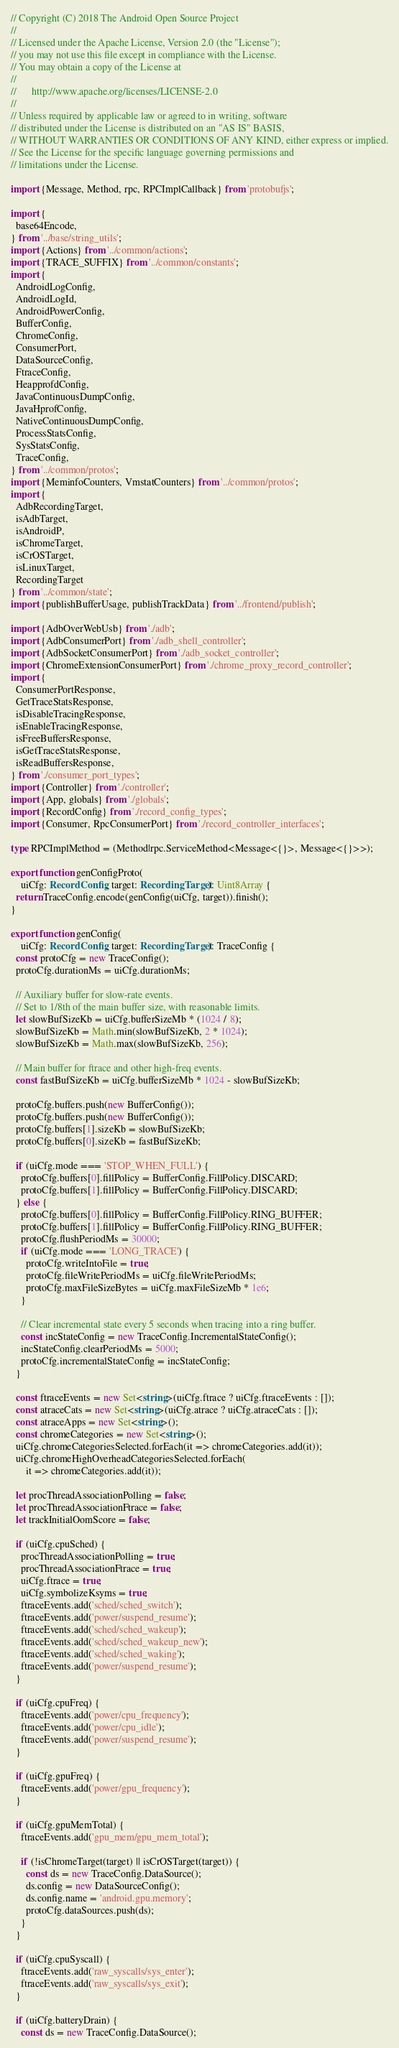<code> <loc_0><loc_0><loc_500><loc_500><_TypeScript_>// Copyright (C) 2018 The Android Open Source Project
//
// Licensed under the Apache License, Version 2.0 (the "License");
// you may not use this file except in compliance with the License.
// You may obtain a copy of the License at
//
//      http://www.apache.org/licenses/LICENSE-2.0
//
// Unless required by applicable law or agreed to in writing, software
// distributed under the License is distributed on an "AS IS" BASIS,
// WITHOUT WARRANTIES OR CONDITIONS OF ANY KIND, either express or implied.
// See the License for the specific language governing permissions and
// limitations under the License.

import {Message, Method, rpc, RPCImplCallback} from 'protobufjs';

import {
  base64Encode,
} from '../base/string_utils';
import {Actions} from '../common/actions';
import {TRACE_SUFFIX} from '../common/constants';
import {
  AndroidLogConfig,
  AndroidLogId,
  AndroidPowerConfig,
  BufferConfig,
  ChromeConfig,
  ConsumerPort,
  DataSourceConfig,
  FtraceConfig,
  HeapprofdConfig,
  JavaContinuousDumpConfig,
  JavaHprofConfig,
  NativeContinuousDumpConfig,
  ProcessStatsConfig,
  SysStatsConfig,
  TraceConfig,
} from '../common/protos';
import {MeminfoCounters, VmstatCounters} from '../common/protos';
import {
  AdbRecordingTarget,
  isAdbTarget,
  isAndroidP,
  isChromeTarget,
  isCrOSTarget,
  isLinuxTarget,
  RecordingTarget
} from '../common/state';
import {publishBufferUsage, publishTrackData} from '../frontend/publish';

import {AdbOverWebUsb} from './adb';
import {AdbConsumerPort} from './adb_shell_controller';
import {AdbSocketConsumerPort} from './adb_socket_controller';
import {ChromeExtensionConsumerPort} from './chrome_proxy_record_controller';
import {
  ConsumerPortResponse,
  GetTraceStatsResponse,
  isDisableTracingResponse,
  isEnableTracingResponse,
  isFreeBuffersResponse,
  isGetTraceStatsResponse,
  isReadBuffersResponse,
} from './consumer_port_types';
import {Controller} from './controller';
import {App, globals} from './globals';
import {RecordConfig} from './record_config_types';
import {Consumer, RpcConsumerPort} from './record_controller_interfaces';

type RPCImplMethod = (Method|rpc.ServiceMethod<Message<{}>, Message<{}>>);

export function genConfigProto(
    uiCfg: RecordConfig, target: RecordingTarget): Uint8Array {
  return TraceConfig.encode(genConfig(uiCfg, target)).finish();
}

export function genConfig(
    uiCfg: RecordConfig, target: RecordingTarget): TraceConfig {
  const protoCfg = new TraceConfig();
  protoCfg.durationMs = uiCfg.durationMs;

  // Auxiliary buffer for slow-rate events.
  // Set to 1/8th of the main buffer size, with reasonable limits.
  let slowBufSizeKb = uiCfg.bufferSizeMb * (1024 / 8);
  slowBufSizeKb = Math.min(slowBufSizeKb, 2 * 1024);
  slowBufSizeKb = Math.max(slowBufSizeKb, 256);

  // Main buffer for ftrace and other high-freq events.
  const fastBufSizeKb = uiCfg.bufferSizeMb * 1024 - slowBufSizeKb;

  protoCfg.buffers.push(new BufferConfig());
  protoCfg.buffers.push(new BufferConfig());
  protoCfg.buffers[1].sizeKb = slowBufSizeKb;
  protoCfg.buffers[0].sizeKb = fastBufSizeKb;

  if (uiCfg.mode === 'STOP_WHEN_FULL') {
    protoCfg.buffers[0].fillPolicy = BufferConfig.FillPolicy.DISCARD;
    protoCfg.buffers[1].fillPolicy = BufferConfig.FillPolicy.DISCARD;
  } else {
    protoCfg.buffers[0].fillPolicy = BufferConfig.FillPolicy.RING_BUFFER;
    protoCfg.buffers[1].fillPolicy = BufferConfig.FillPolicy.RING_BUFFER;
    protoCfg.flushPeriodMs = 30000;
    if (uiCfg.mode === 'LONG_TRACE') {
      protoCfg.writeIntoFile = true;
      protoCfg.fileWritePeriodMs = uiCfg.fileWritePeriodMs;
      protoCfg.maxFileSizeBytes = uiCfg.maxFileSizeMb * 1e6;
    }

    // Clear incremental state every 5 seconds when tracing into a ring buffer.
    const incStateConfig = new TraceConfig.IncrementalStateConfig();
    incStateConfig.clearPeriodMs = 5000;
    protoCfg.incrementalStateConfig = incStateConfig;
  }

  const ftraceEvents = new Set<string>(uiCfg.ftrace ? uiCfg.ftraceEvents : []);
  const atraceCats = new Set<string>(uiCfg.atrace ? uiCfg.atraceCats : []);
  const atraceApps = new Set<string>();
  const chromeCategories = new Set<string>();
  uiCfg.chromeCategoriesSelected.forEach(it => chromeCategories.add(it));
  uiCfg.chromeHighOverheadCategoriesSelected.forEach(
      it => chromeCategories.add(it));

  let procThreadAssociationPolling = false;
  let procThreadAssociationFtrace = false;
  let trackInitialOomScore = false;

  if (uiCfg.cpuSched) {
    procThreadAssociationPolling = true;
    procThreadAssociationFtrace = true;
    uiCfg.ftrace = true;
    uiCfg.symbolizeKsyms = true;
    ftraceEvents.add('sched/sched_switch');
    ftraceEvents.add('power/suspend_resume');
    ftraceEvents.add('sched/sched_wakeup');
    ftraceEvents.add('sched/sched_wakeup_new');
    ftraceEvents.add('sched/sched_waking');
    ftraceEvents.add('power/suspend_resume');
  }

  if (uiCfg.cpuFreq) {
    ftraceEvents.add('power/cpu_frequency');
    ftraceEvents.add('power/cpu_idle');
    ftraceEvents.add('power/suspend_resume');
  }

  if (uiCfg.gpuFreq) {
    ftraceEvents.add('power/gpu_frequency');
  }

  if (uiCfg.gpuMemTotal) {
    ftraceEvents.add('gpu_mem/gpu_mem_total');

    if (!isChromeTarget(target) || isCrOSTarget(target)) {
      const ds = new TraceConfig.DataSource();
      ds.config = new DataSourceConfig();
      ds.config.name = 'android.gpu.memory';
      protoCfg.dataSources.push(ds);
    }
  }

  if (uiCfg.cpuSyscall) {
    ftraceEvents.add('raw_syscalls/sys_enter');
    ftraceEvents.add('raw_syscalls/sys_exit');
  }

  if (uiCfg.batteryDrain) {
    const ds = new TraceConfig.DataSource();</code> 